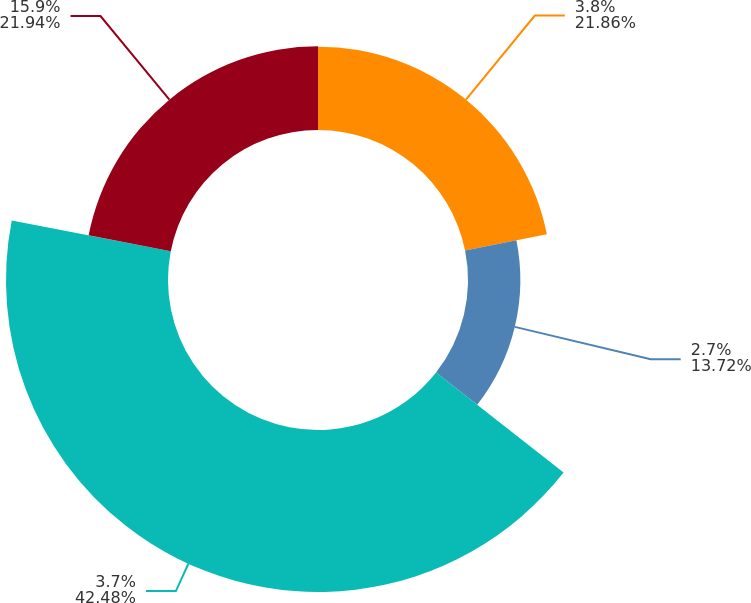<chart> <loc_0><loc_0><loc_500><loc_500><pie_chart><fcel>3.8%<fcel>2.7%<fcel>3.7%<fcel>15.9%<nl><fcel>21.86%<fcel>13.72%<fcel>42.48%<fcel>21.94%<nl></chart> 